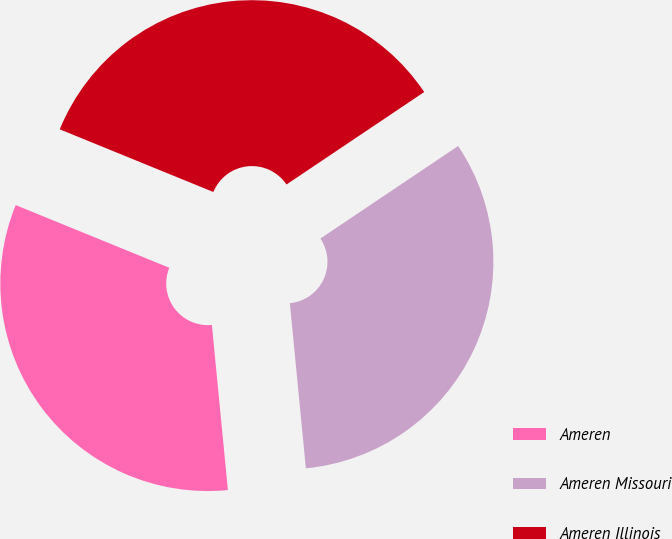Convert chart. <chart><loc_0><loc_0><loc_500><loc_500><pie_chart><fcel>Ameren<fcel>Ameren Missouri<fcel>Ameren Illinois<nl><fcel>32.7%<fcel>32.87%<fcel>34.42%<nl></chart> 